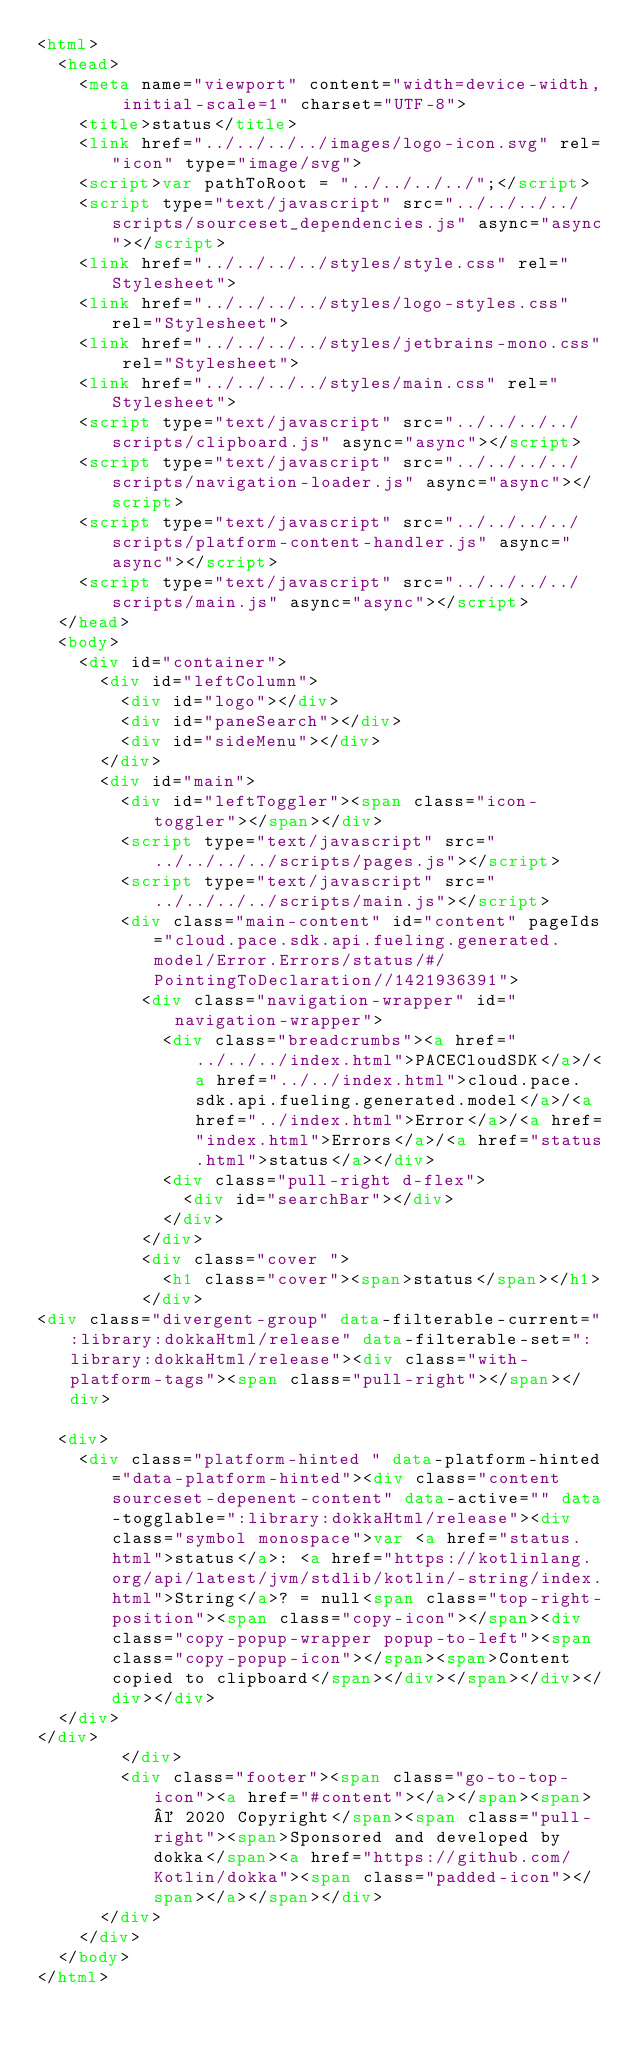Convert code to text. <code><loc_0><loc_0><loc_500><loc_500><_HTML_><html>
  <head>
    <meta name="viewport" content="width=device-width, initial-scale=1" charset="UTF-8">
    <title>status</title>
    <link href="../../../../images/logo-icon.svg" rel="icon" type="image/svg">
    <script>var pathToRoot = "../../../../";</script>
    <script type="text/javascript" src="../../../../scripts/sourceset_dependencies.js" async="async"></script>
    <link href="../../../../styles/style.css" rel="Stylesheet">
    <link href="../../../../styles/logo-styles.css" rel="Stylesheet">
    <link href="../../../../styles/jetbrains-mono.css" rel="Stylesheet">
    <link href="../../../../styles/main.css" rel="Stylesheet">
    <script type="text/javascript" src="../../../../scripts/clipboard.js" async="async"></script>
    <script type="text/javascript" src="../../../../scripts/navigation-loader.js" async="async"></script>
    <script type="text/javascript" src="../../../../scripts/platform-content-handler.js" async="async"></script>
    <script type="text/javascript" src="../../../../scripts/main.js" async="async"></script>
  </head>
  <body>
    <div id="container">
      <div id="leftColumn">
        <div id="logo"></div>
        <div id="paneSearch"></div>
        <div id="sideMenu"></div>
      </div>
      <div id="main">
        <div id="leftToggler"><span class="icon-toggler"></span></div>
        <script type="text/javascript" src="../../../../scripts/pages.js"></script>
        <script type="text/javascript" src="../../../../scripts/main.js"></script>
        <div class="main-content" id="content" pageIds="cloud.pace.sdk.api.fueling.generated.model/Error.Errors/status/#/PointingToDeclaration//1421936391">
          <div class="navigation-wrapper" id="navigation-wrapper">
            <div class="breadcrumbs"><a href="../../../index.html">PACECloudSDK</a>/<a href="../../index.html">cloud.pace.sdk.api.fueling.generated.model</a>/<a href="../index.html">Error</a>/<a href="index.html">Errors</a>/<a href="status.html">status</a></div>
            <div class="pull-right d-flex">
              <div id="searchBar"></div>
            </div>
          </div>
          <div class="cover ">
            <h1 class="cover"><span>status</span></h1>
          </div>
<div class="divergent-group" data-filterable-current=":library:dokkaHtml/release" data-filterable-set=":library:dokkaHtml/release"><div class="with-platform-tags"><span class="pull-right"></span></div>

  <div>
    <div class="platform-hinted " data-platform-hinted="data-platform-hinted"><div class="content sourceset-depenent-content" data-active="" data-togglable=":library:dokkaHtml/release"><div class="symbol monospace">var <a href="status.html">status</a>: <a href="https://kotlinlang.org/api/latest/jvm/stdlib/kotlin/-string/index.html">String</a>? = null<span class="top-right-position"><span class="copy-icon"></span><div class="copy-popup-wrapper popup-to-left"><span class="copy-popup-icon"></span><span>Content copied to clipboard</span></div></span></div></div></div>
  </div>
</div>
        </div>
        <div class="footer"><span class="go-to-top-icon"><a href="#content"></a></span><span>© 2020 Copyright</span><span class="pull-right"><span>Sponsored and developed by dokka</span><a href="https://github.com/Kotlin/dokka"><span class="padded-icon"></span></a></span></div>
      </div>
    </div>
  </body>
</html>

</code> 